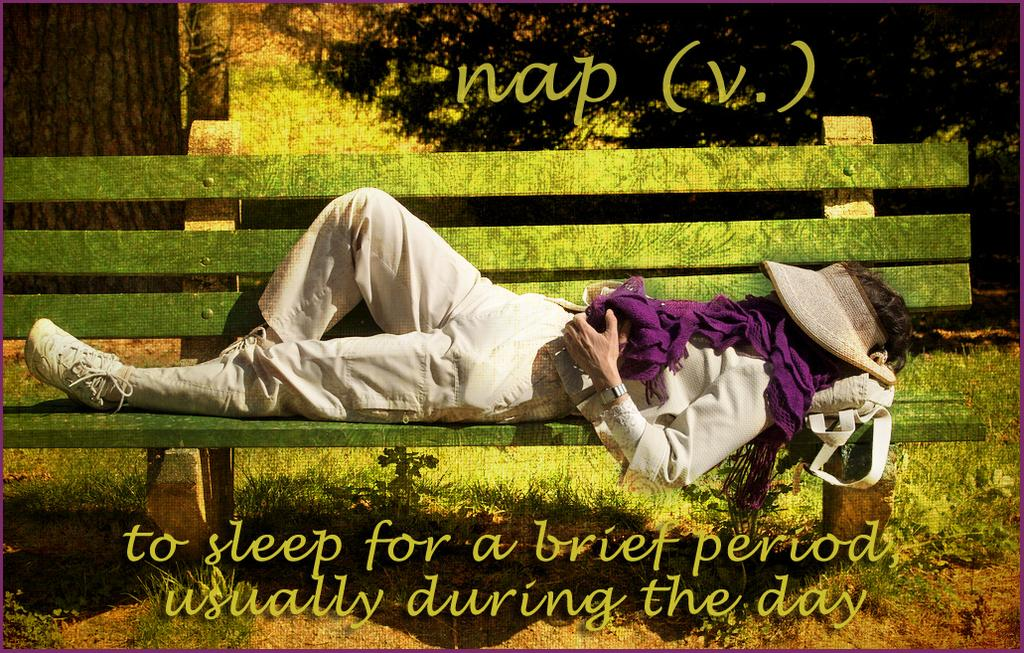What is featured on the poster in the image? The poster contains text in the image. What type of surface is visible in the image? There is a ground with grass in the image. What can be found on the ground in the image? There are plants on the ground in the image. What is the man in the image doing? A man is sleeping on a bench in the middle of the image. What type of soda is the man holding in the image? There is no soda present in the image; the man is sleeping on a bench. How many feet are visible in the image? The image does not show any feet; it only shows a man sleeping on a bench. 